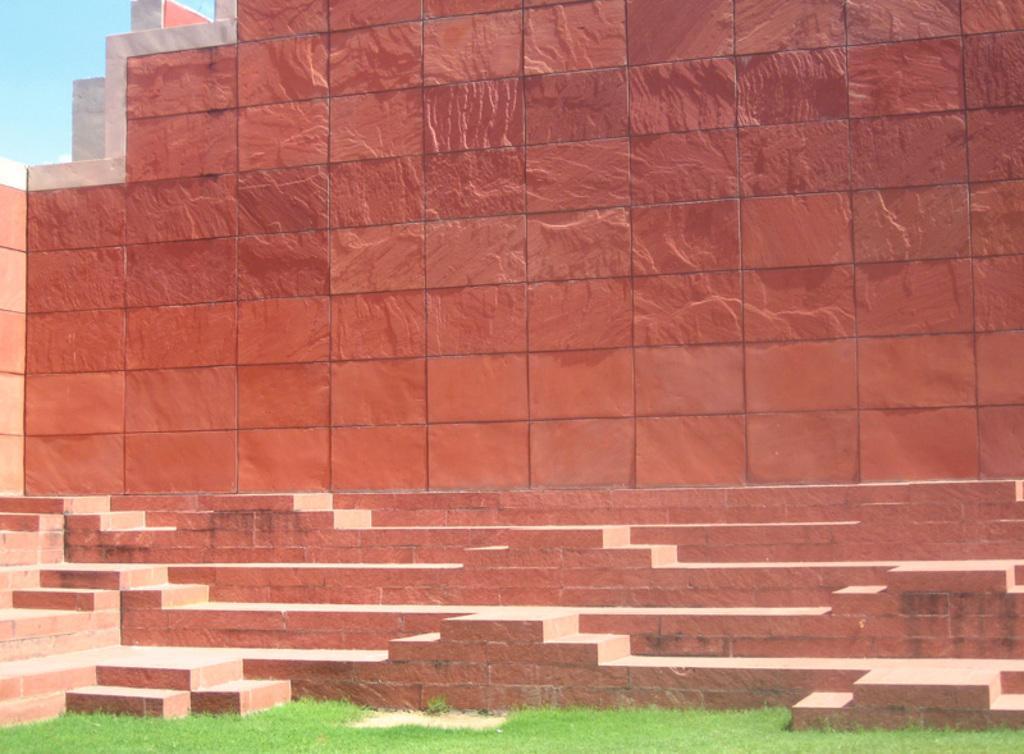How would you summarize this image in a sentence or two? In this image, we can see a wall and there is green grass on the ground. 